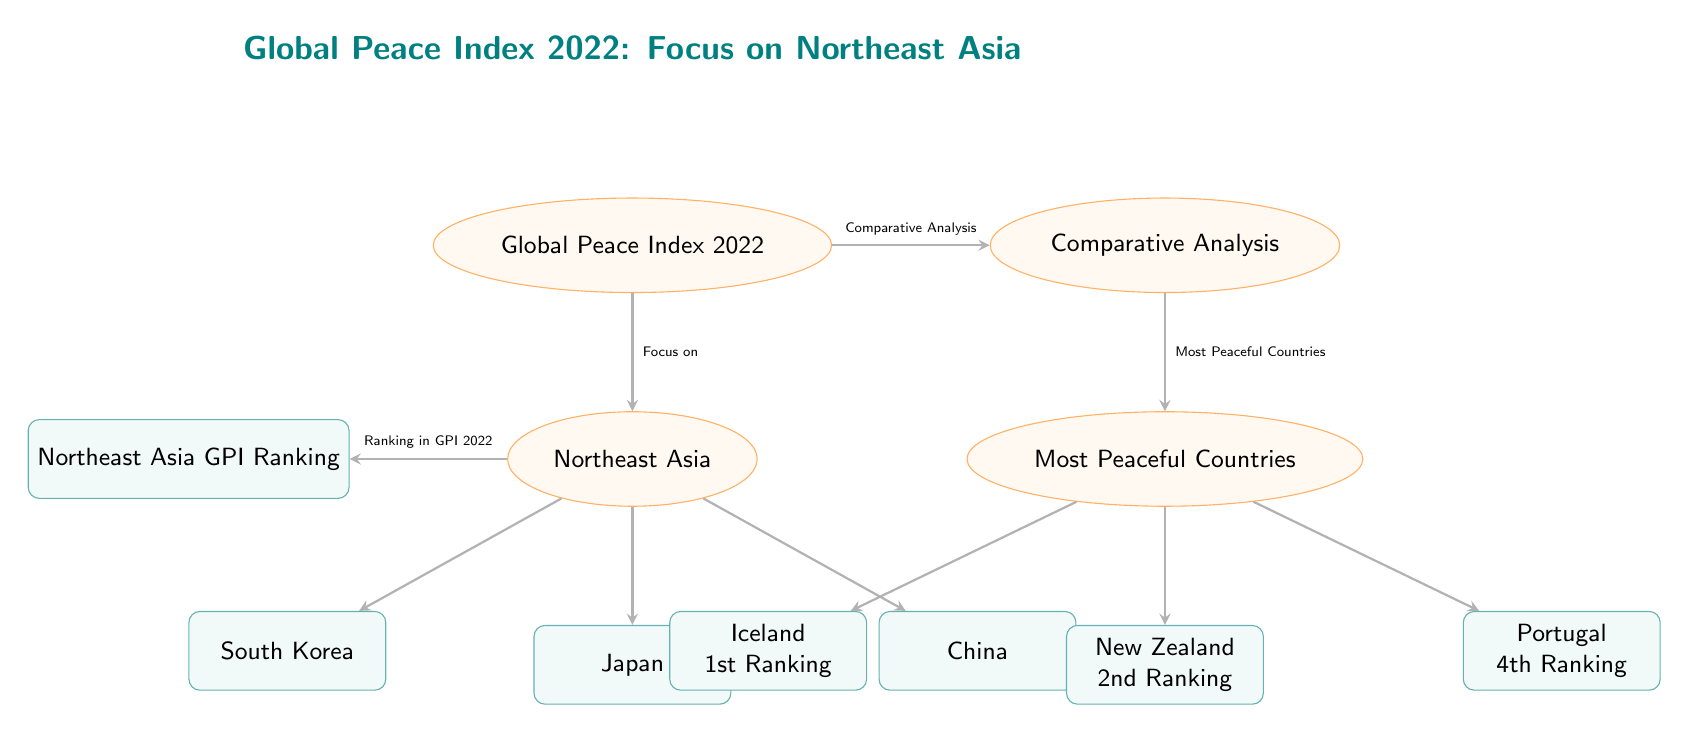What is the focus of the Global Peace Index 2022 diagram? The diagram indicates that the focus is on Northeast Asia, which is shown directly under the Global Peace Index node with an arrow pointing from it.
Answer: Northeast Asia Which country is ranked 1st in the Most Peaceful Countries section? The diagram clearly lists Iceland as the 1st ranked country under the Most Peaceful Countries node, which has an arrow pointing to Iceland.
Answer: Iceland How many countries are highlighted in the Northeast Asia section? There are three countries listed under the Northeast Asia node: South Korea, Japan, and China. Counting these countries gives a total of three.
Answer: Three What is the second ranking country among the Most Peaceful Countries? According to the diagram, New Zealand is shown as the 2nd ranking country under the Most Peaceful Countries node, indicated by its position.
Answer: New Zealand Which node shows the ranking in the GPI 2022 for Northeast Asia? The node labeled "Northeast Asia GPI Ranking" connects with the Northeast Asia node through an arrow, indicating that it shows the ranking of that region.
Answer: Northeast Asia GPI Ranking What does the arrow from Global Peace Index point to besides Northeast Asia? There is another arrow pointing to the Comparative Analysis node from the Global Peace Index, indicating that it also focuses on comparative analysis.
Answer: Comparative Analysis How is the information about the Most Peaceful Countries connected to the Global Peace Index? The diagram shows an arrow from the Comparative Analysis node to the Most Peaceful Countries, indicating that comparisons are made based on the Global Peace Index information.
Answer: Through Comparative Analysis What is the ranking position of Portugal among the Most Peaceful Countries? The diagram specifies that Portugal is in 4th ranking under the Most Peaceful Countries section, as indicated next to its name.
Answer: 4th Ranking What color represents the nodes related to countries in the diagram? The box nodes representing countries have a teal color fill, as indicated in the styling options provided in the code.
Answer: Teal 